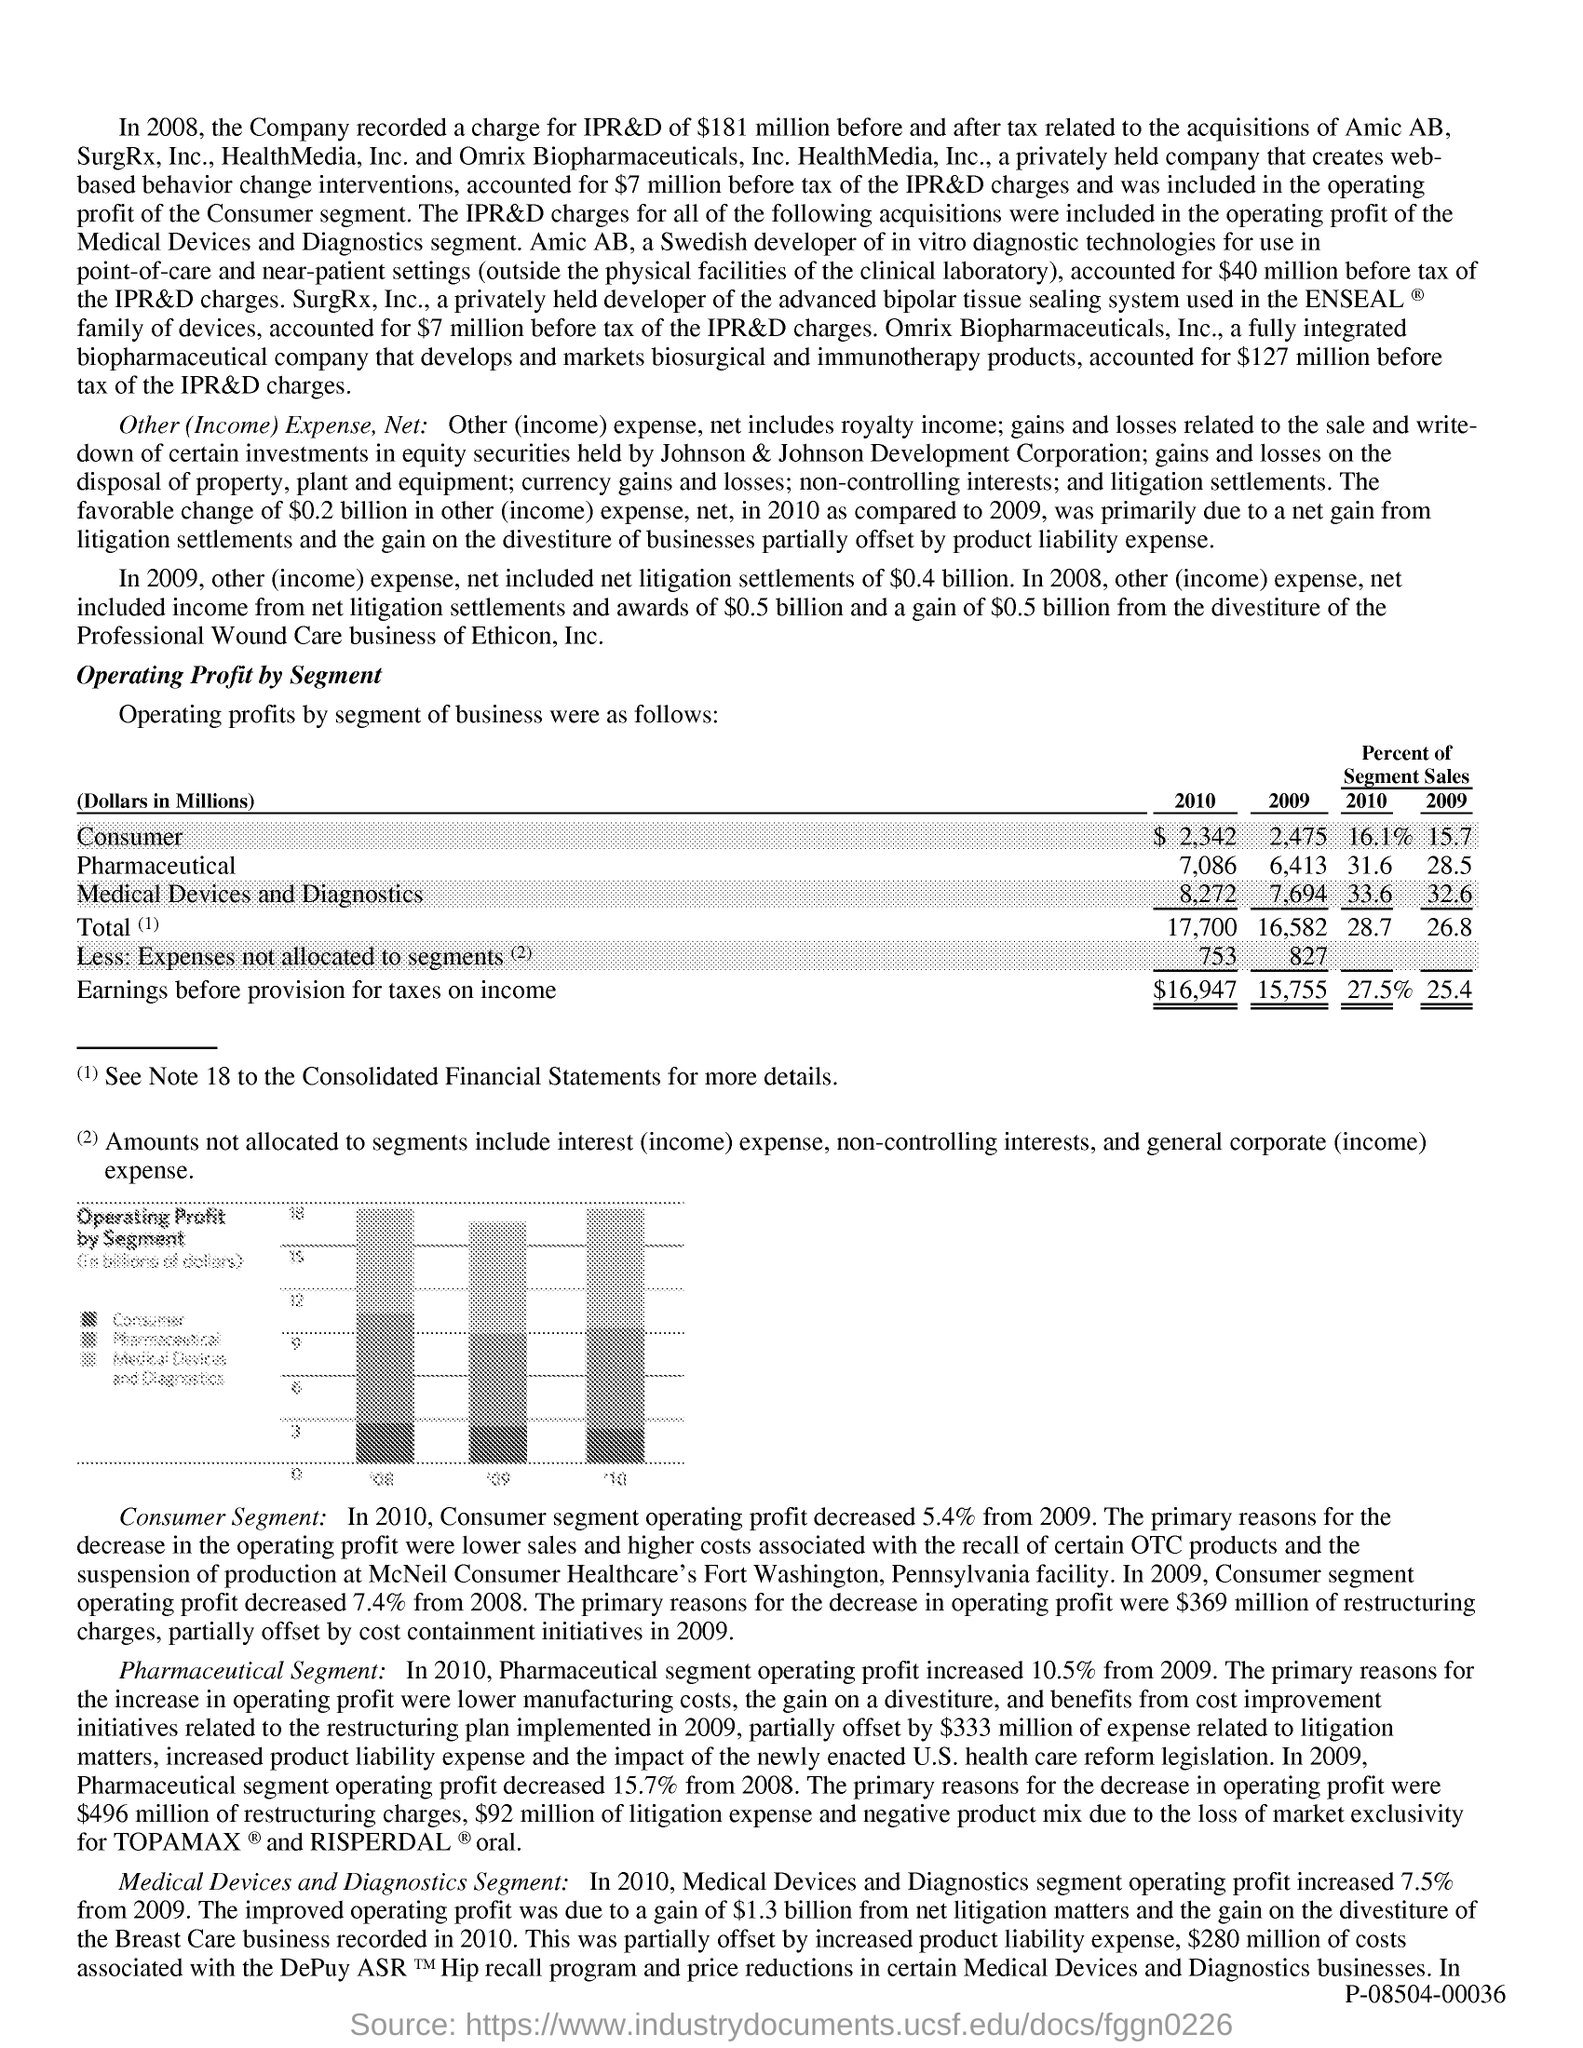What is the first title in the document?
Ensure brevity in your answer.  Operating Profit by segment. 